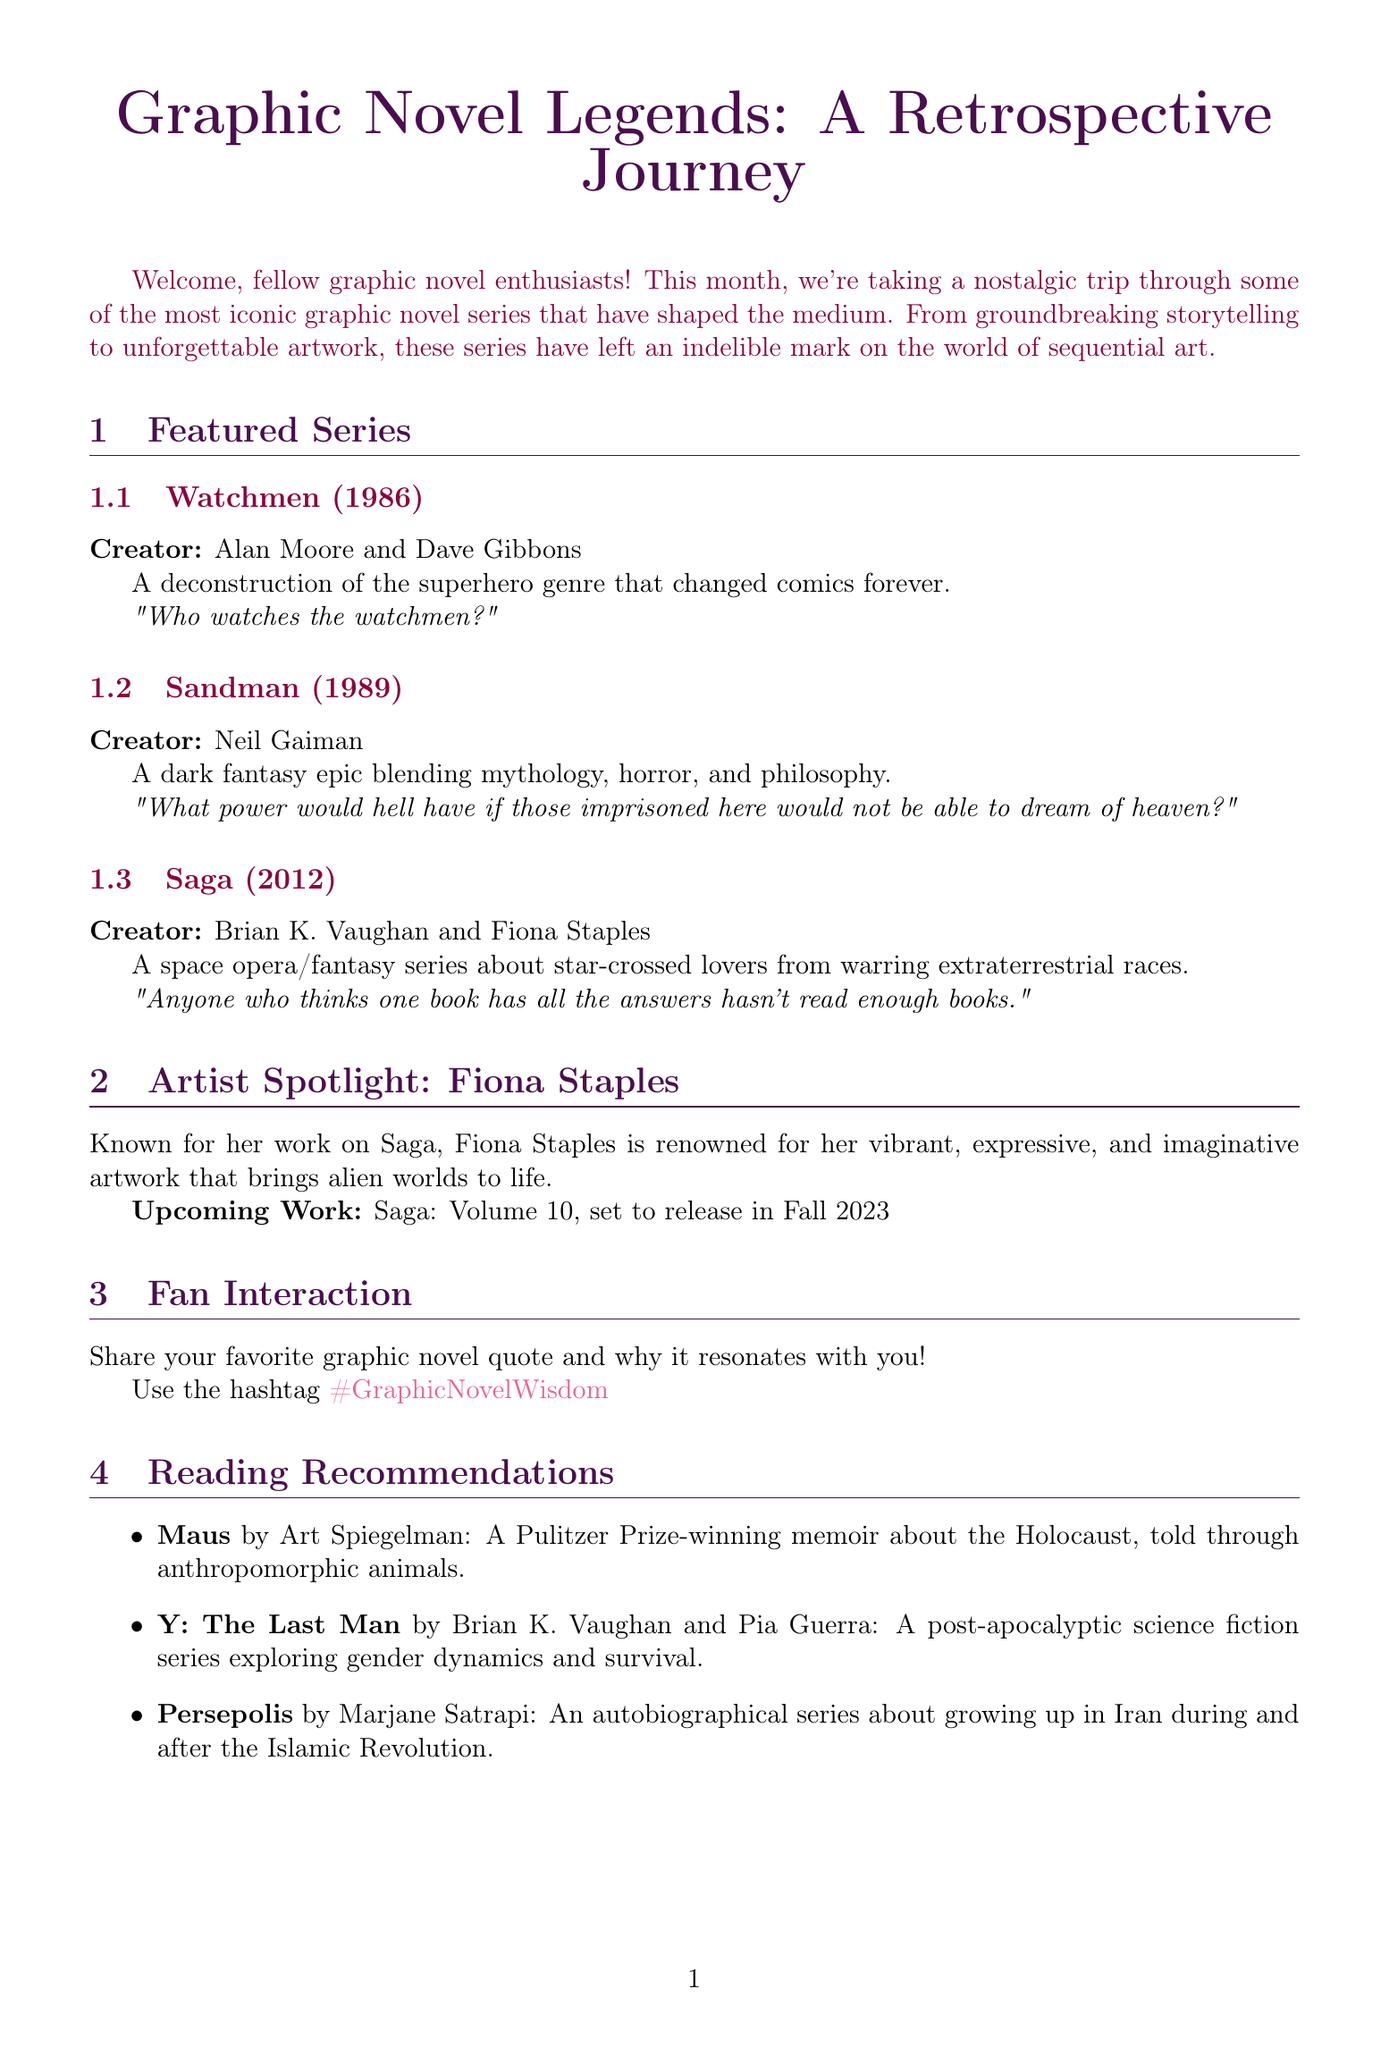What is the title of the newsletter? The title of the newsletter is presented at the beginning of the document, indicating the subject matter.
Answer: Graphic Novel Legends: A Retrospective Journey Who is the creator of "Sandman"? The document lists the creators of each featured graphic novel series, including the specific creator of "Sandman".
Answer: Neil Gaiman What year was "Watchmen" released? The release year for "Watchmen" is directly mentioned in the section describing the series.
Answer: 1986 Which graphic novel series includes a character named Morpheus? The document provides details about characters in the featured series, including one named Morpheus.
Answer: Sandman What upcoming work is Fiona Staples known for? The document highlights upcoming work from the featured artist, including the specific title.
Answer: Saga: Volume 10 What is the hashtag used for fan interaction? The document specifies a hashtag for the fan interaction section, encouraging readers to share quotes.
Answer: #GraphicNovelWisdom What genre does "Saga" represent? The description of "Saga" includes specific genres that characterize the series, indicating its classification.
Answer: Space opera/fantasy What type of memoir is "Maus"? The document categorizes "Maus" within specific genres, providing insight into the story's nature.
Answer: Pulitzer Prize-winning memoir What is the main theme of "Persepolis"? The description of "Persepolis" focuses on the story's central experiences, revealing its thematic content.
Answer: Growing up in Iran during and after the Islamic Revolution 